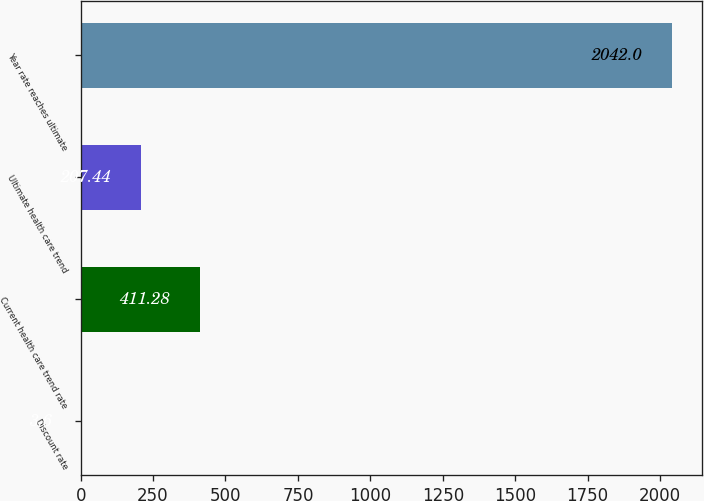<chart> <loc_0><loc_0><loc_500><loc_500><bar_chart><fcel>Discount rate<fcel>Current health care trend rate<fcel>Ultimate health care trend<fcel>Year rate reaches ultimate<nl><fcel>3.6<fcel>411.28<fcel>207.44<fcel>2042<nl></chart> 